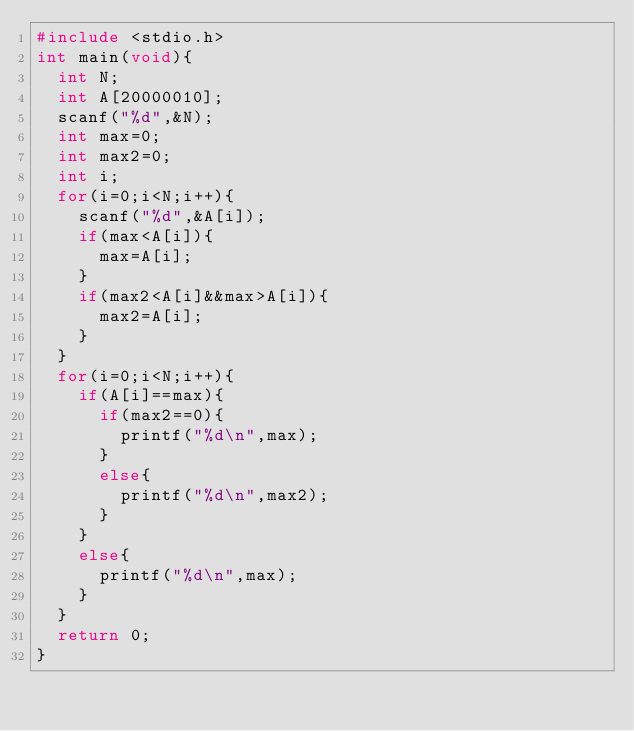Convert code to text. <code><loc_0><loc_0><loc_500><loc_500><_C_>#include <stdio.h>
int main(void){
  int N;
  int A[20000010];
  scanf("%d",&N);
  int max=0;
  int max2=0;
  int i;
  for(i=0;i<N;i++){
    scanf("%d",&A[i]);
    if(max<A[i]){
      max=A[i];
    }
    if(max2<A[i]&&max>A[i]){
      max2=A[i];
    }
  }
  for(i=0;i<N;i++){
    if(A[i]==max){
      if(max2==0){
        printf("%d\n",max);
      }
      else{
        printf("%d\n",max2);
      }
    }
    else{
      printf("%d\n",max);
    }
  }
  return 0;
}</code> 